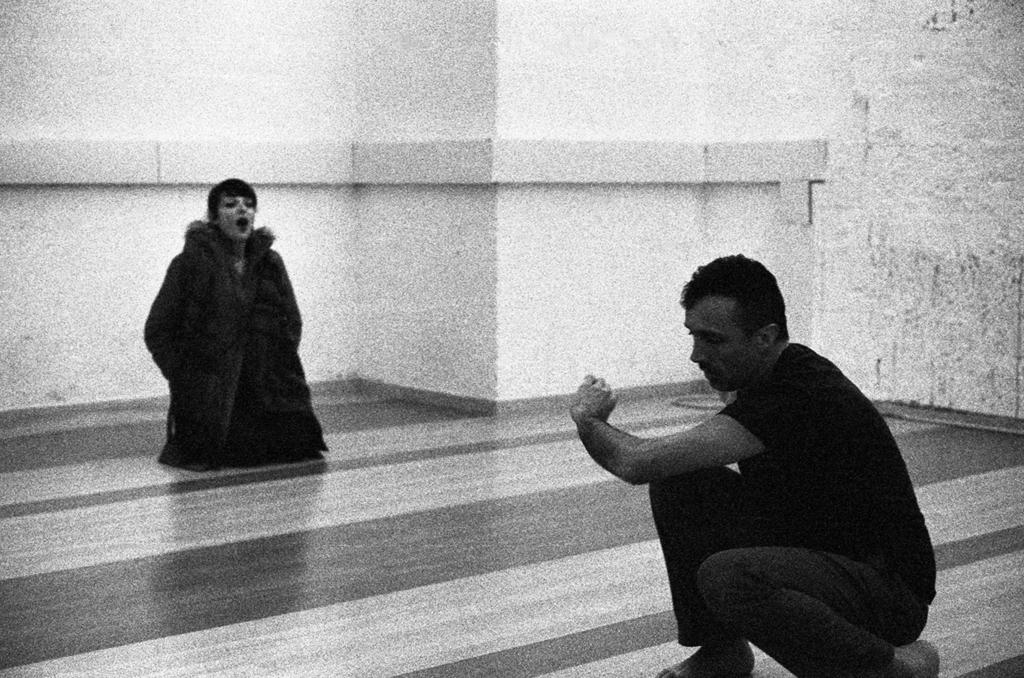How many people are in the image? There are two persons visible in the image. What are the persons doing in the image? The persons are on the floor. What can be seen in the middle of the image? There is a wall in the middle of the image. What type of scarf is draped over the yard in the image? There is no scarf or yard present in the image. How many plates are visible on the wall in the image? There are no plates visible on the wall in the image. 